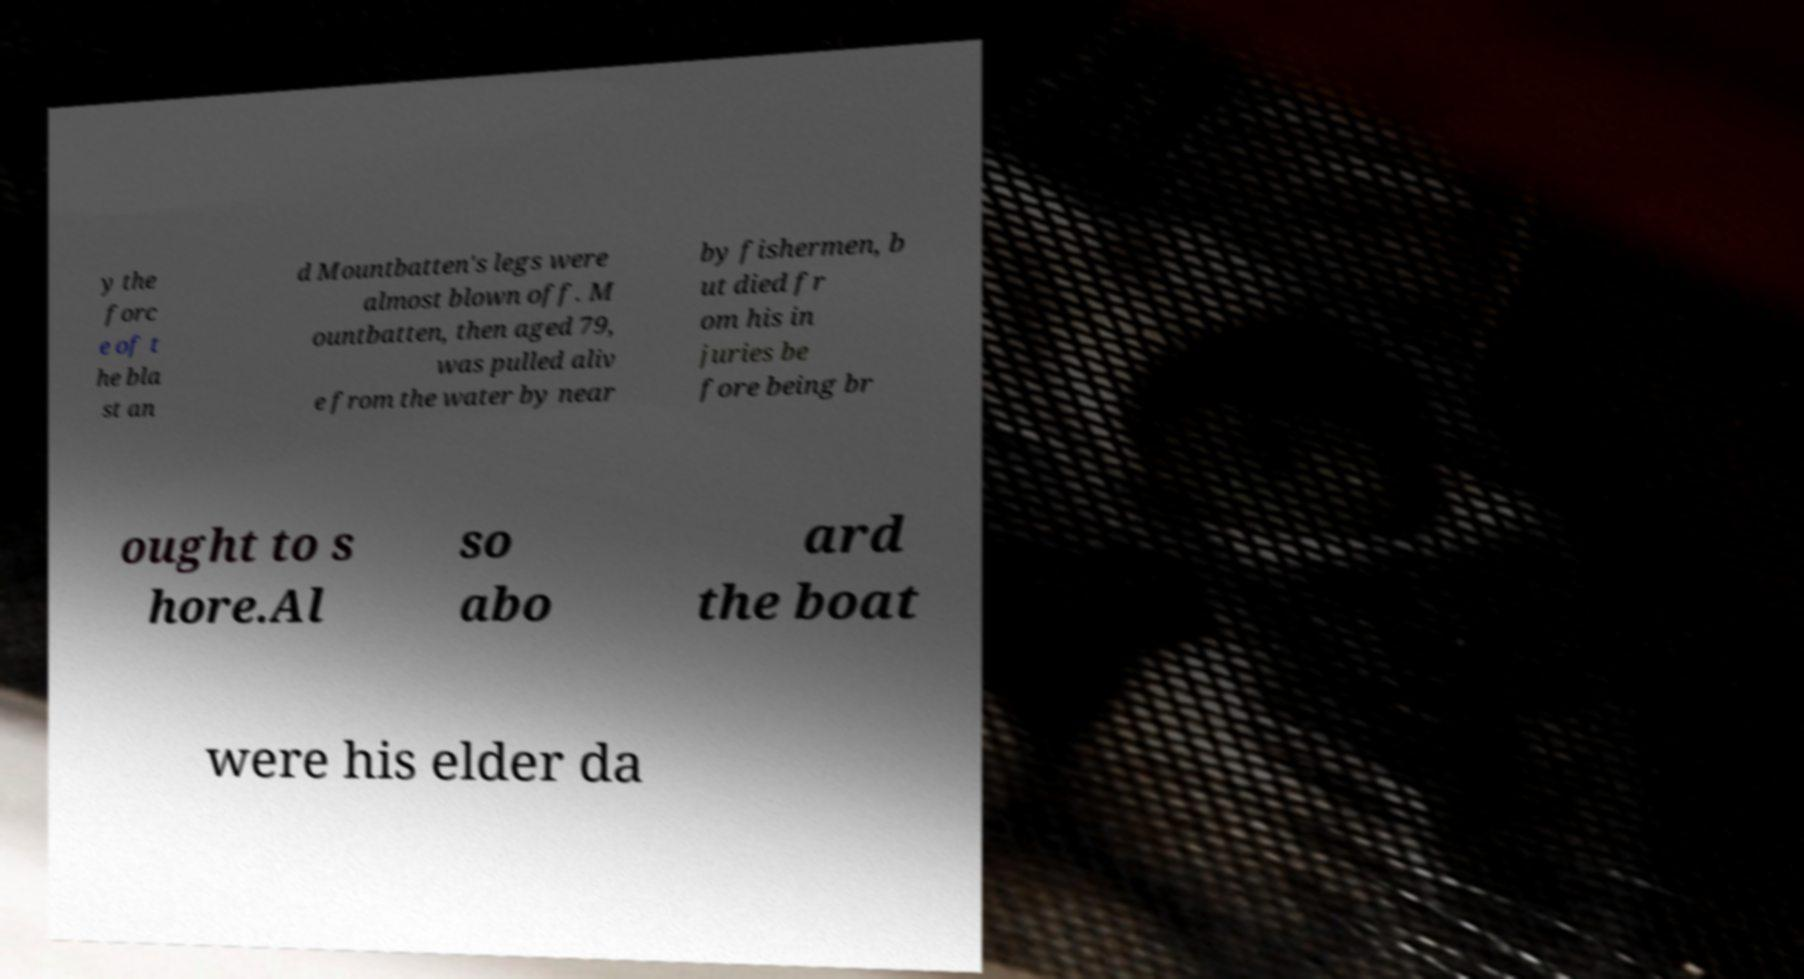Could you extract and type out the text from this image? y the forc e of t he bla st an d Mountbatten's legs were almost blown off. M ountbatten, then aged 79, was pulled aliv e from the water by near by fishermen, b ut died fr om his in juries be fore being br ought to s hore.Al so abo ard the boat were his elder da 